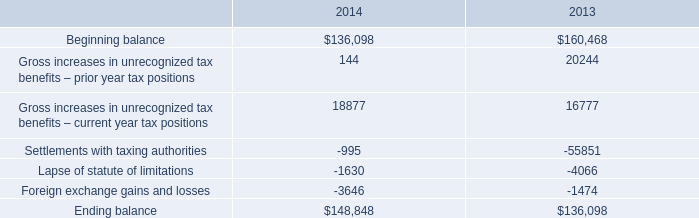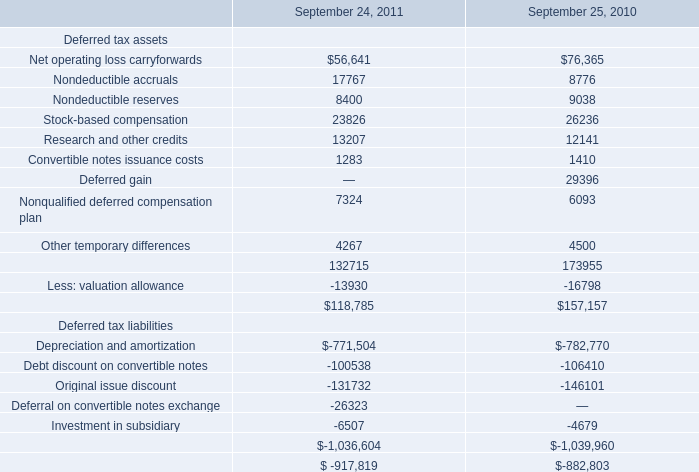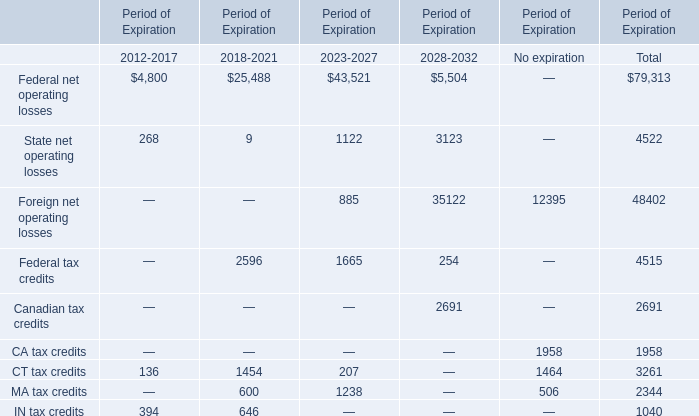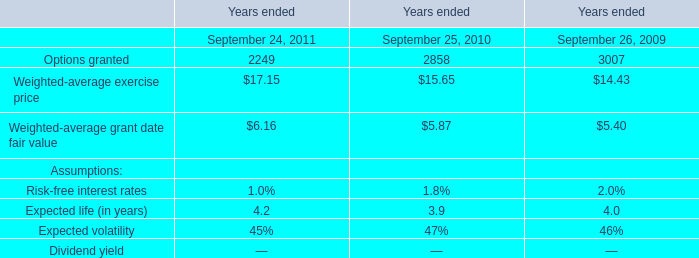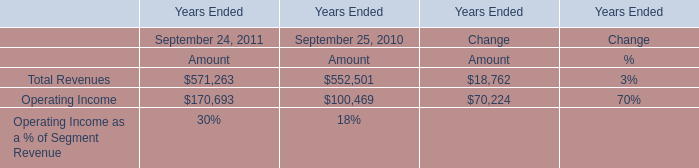what is the percentage change in the total gross amount of unrecognized tax benefits from 2013 to 2014? 
Computations: ((148848 - 136098) / 136098)
Answer: 0.09368. 